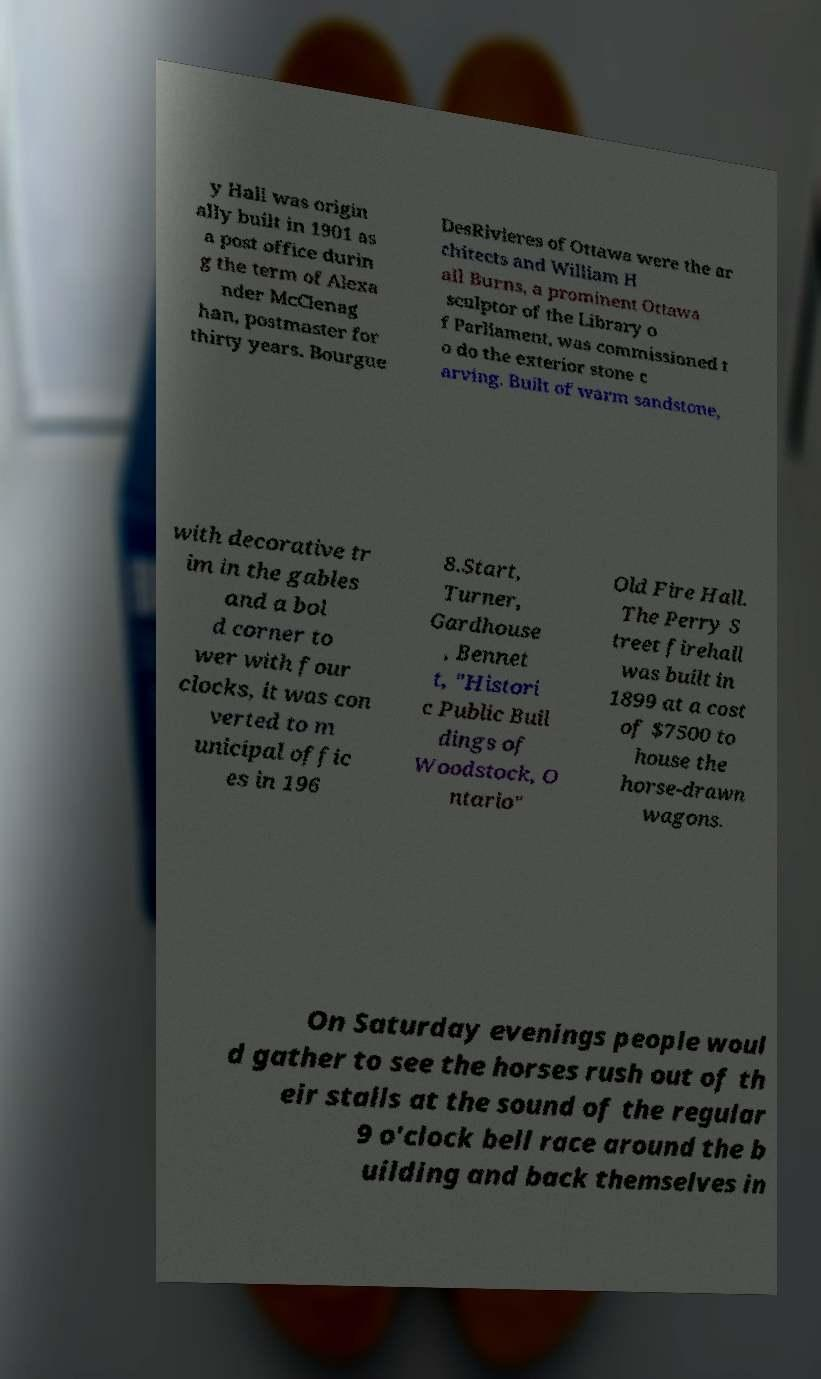Can you accurately transcribe the text from the provided image for me? y Hall was origin ally built in 1901 as a post office durin g the term of Alexa nder McClenag han, postmaster for thirty years. Bourgue DesRivieres of Ottawa were the ar chitects and William H all Burns, a prominent Ottawa sculptor of the Library o f Parliament, was commissioned t o do the exterior stone c arving. Built of warm sandstone, with decorative tr im in the gables and a bol d corner to wer with four clocks, it was con verted to m unicipal offic es in 196 8.Start, Turner, Gardhouse , Bennet t, "Histori c Public Buil dings of Woodstock, O ntario" Old Fire Hall. The Perry S treet firehall was built in 1899 at a cost of $7500 to house the horse-drawn wagons. On Saturday evenings people woul d gather to see the horses rush out of th eir stalls at the sound of the regular 9 o'clock bell race around the b uilding and back themselves in 